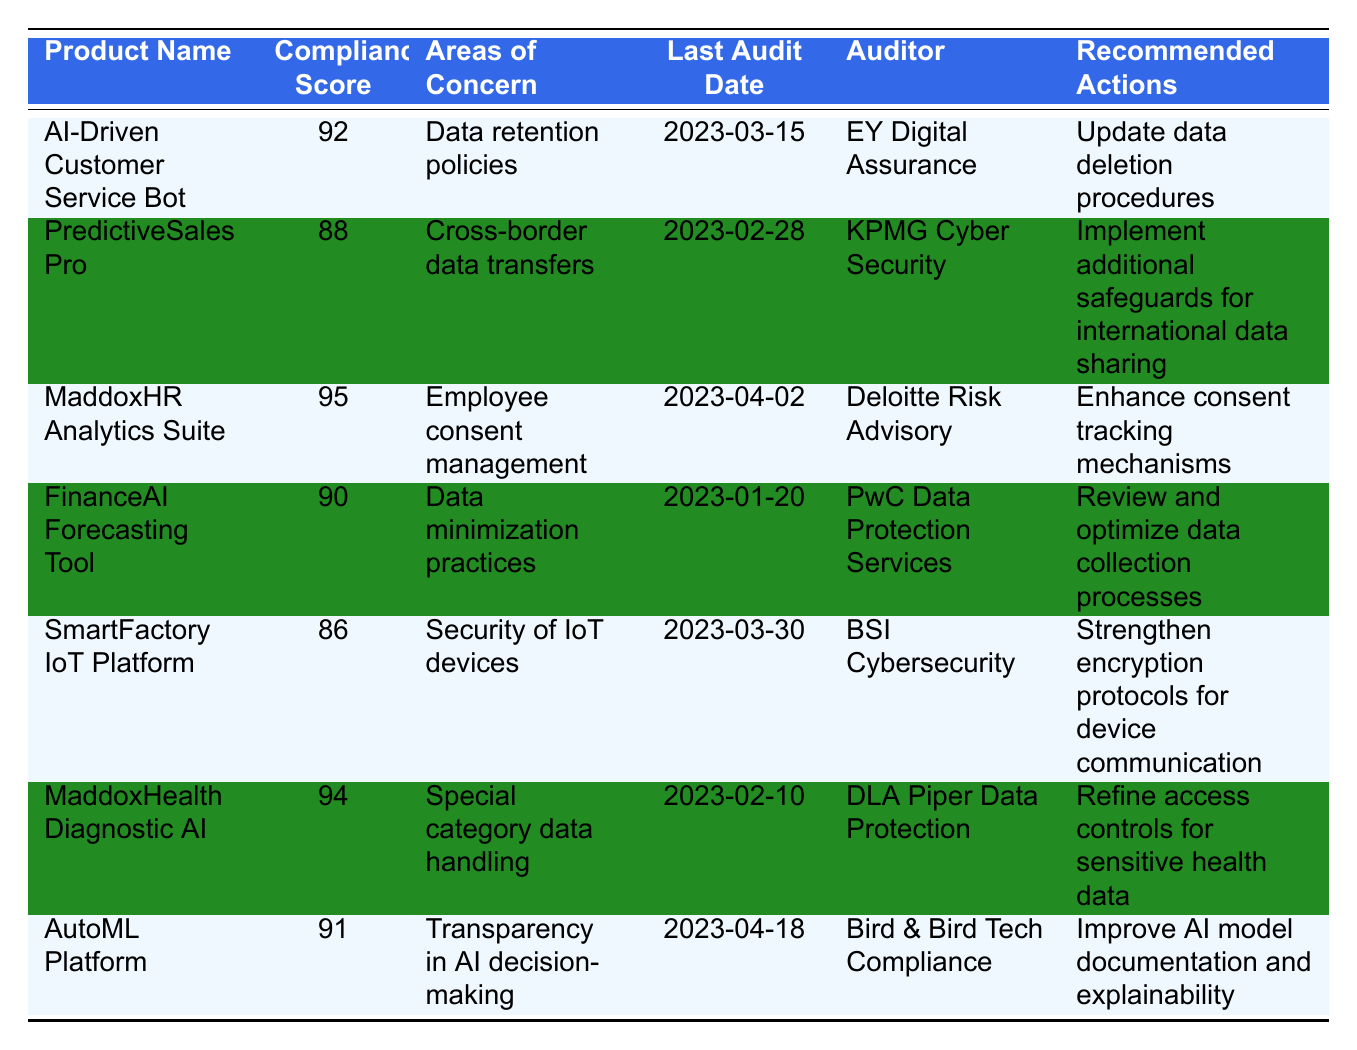What is the compliance score of the AI-Driven Customer Service Bot? The compliance score for the AI-Driven Customer Service Bot is directly listed in the table under the "Compliance Score" column. It shows a score of 92.
Answer: 92 Which product has the highest compliance score? By comparing the compliance scores listed in the table, the MaddoxHR Analytics Suite has the highest score of 95.
Answer: MaddoxHR Analytics Suite Are there any products with compliance scores below 90? The table indicates the compliance scores of all products. The SmartFactory IoT Platform, with a score of 86, is the only product below 90.
Answer: Yes What area of concern is associated with the PredictiveSales Pro? The area of concern listed for the PredictiveSales Pro in the table is "Cross-border data transfers."
Answer: Cross-border data transfers What recommendations were made for the MaddoxHealth Diagnostic AI? The recommended actions found in the table for MaddoxHealth Diagnostic AI state to "Refine access controls for sensitive health data."
Answer: Refine access controls for sensitive health data What is the average compliance score of all products listed? First, total the compliance scores: 92 + 88 + 95 + 90 + 86 + 94 + 91 = 616. Then, divide by the number of products, which is 7: 616 / 7 = 88. Alternatively, count the products and confirm there are 7.
Answer: 88 Which auditor conducted the last audit for the FinanceAI Forecasting Tool? According to the table, the last audit for the FinanceAI Forecasting Tool was conducted by PwC Data Protection Services, as listed in the "Auditor" column.
Answer: PwC Data Protection Services What recommended actions were given for improving transparency in AI decision-making? As per the "Recommended Actions" column for the AutoML Platform, the suggestion was to "Improve AI model documentation and explainability."
Answer: Improve AI model documentation and explainability Has the SmartFactory IoT Platform received any specific recommendations regarding data security? Yes, the recommendation for the SmartFactory IoT Platform is to "Strengthen encryption protocols for device communication," addressing its area of concern.
Answer: Yes Which product had its last audit conducted most recently? By checking the "Last Audit Date" column, it's clear that the AutoML Platform had its last audit on 2023-04-18, which is the most recent date.
Answer: AutoML Platform 